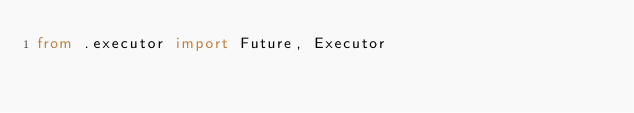Convert code to text. <code><loc_0><loc_0><loc_500><loc_500><_Python_>from .executor import Future, Executor
</code> 